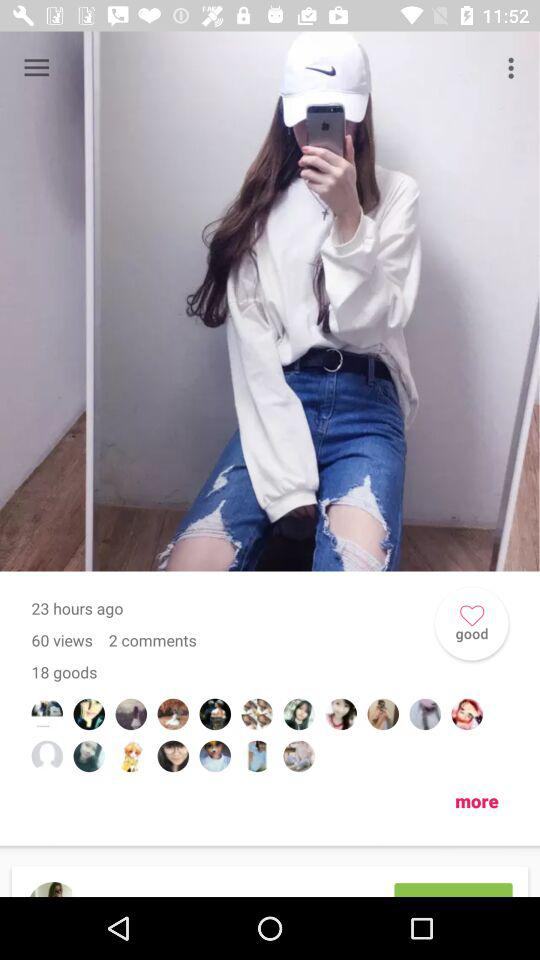When was the photo uploaded? The photo was uploaded 23 hours ago. 